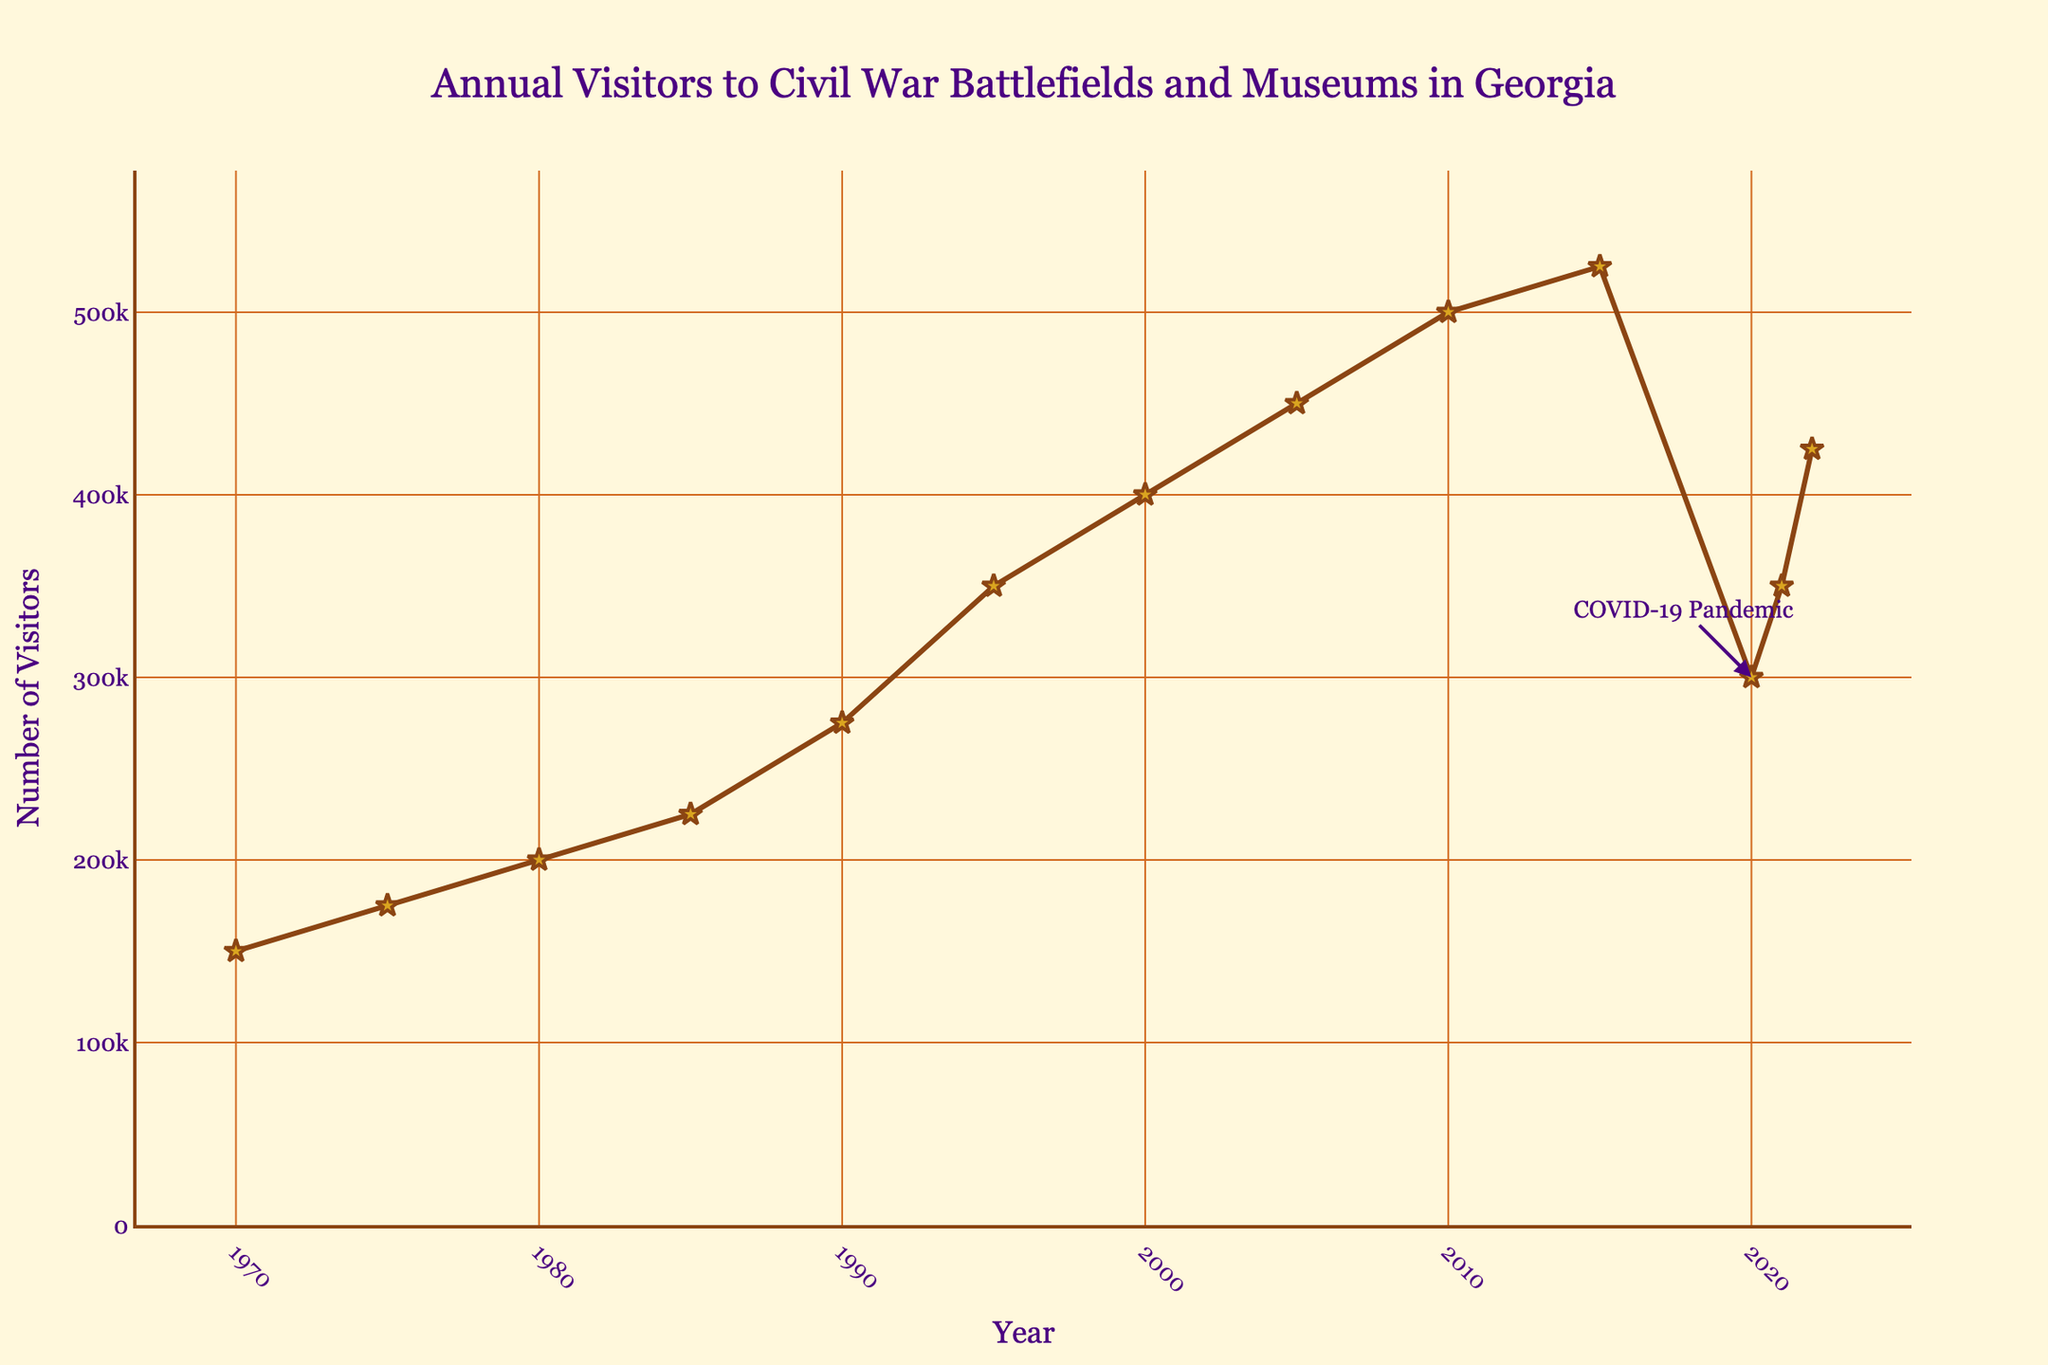What is the general trend in the number of visitors to Civil War battlefields and museums in Georgia from 1970 to 2022? The general trend can be identified by looking at the slope of the line between 1970 and 2022. From 1970 to around 2015, there is a consistent upward trend in the number of visitors. However, it sharply drops in 2020 and then rises again by 2022.
Answer: Upward overall with a dip in 2020 How many years did it take for the number of visitors to double from 150,000 to 300,000? First, find the year when the visitors reached 300,000 (2020). The visitors were 150,000 in 1970. It took 2020 - 1970 = 50 years.
Answer: 50 years How does the number of visitors in 2020 compare to the number of visitors in 2010? Determine the visitors in 2020 (300,000) and visitors in 2010 (500,000) from the plot. Then compare them: 300,000 < 500,000.
Answer: Less Which year saw the highest number of visitors, and what was the number? Locate the highest point on the line. The highest point is in 2015 with 525,000 visitors.
Answer: 2015, 525,000 By what percentage did the number of visitors decline from 2015 to 2020? Calculate the decline by subtracting the number of visitors in 2020 from 2015 (525,000 - 300,000 = 225,000). Then, divide the decline by the number of visitors in 2015 and multiply by 100: (225,000 / 525,000) * 100 ≈ 42.86%.
Answer: 42.86% What is the average number of visitors per year from 1970 to 2022? Sum the number of visitors from 1970 to 2022 and divide by the number of years (53). (150,000 + 175,000 + 200,000 + 225,000 + 275,000 + 350,000 + 400,000 + 450,000 + 500,000 + 525,000 + 300,000 + 350,000 + 425,000) / 13 = 350,000.
Answer: 350,000 How did the number of visitors change from 2019 to 2020? There is no data for 2019, but use 2015 as a proxy to compare changes. Visitors in 2015 were 525,000, which decreased to 300,000 in 2020, showing a significant drop.
Answer: Decreased Which year had the smallest number of visitors after 1980 and what was the number? Examine the points post-1980 and find the smallest value. The smallest number of visitors after 1980 was in 2020 with 300,000 visitors.
Answer: 2020, 300,000 By how much did the number of visitors increase from 1970 to 1990? Find the number of visitors in 1990 (275,000) and in 1970 (150,000). Calculate the increase: 275,000 - 150,000 = 125,000.
Answer: 125,000 